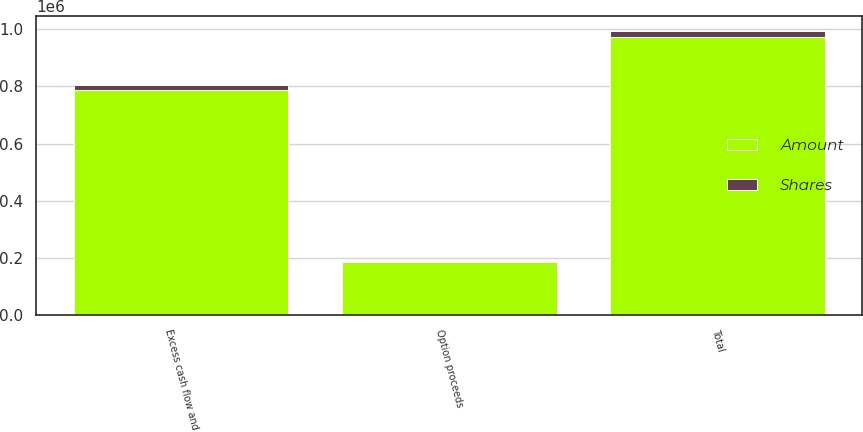<chart> <loc_0><loc_0><loc_500><loc_500><stacked_bar_chart><ecel><fcel>Excess cash flow and<fcel>Option proceeds<fcel>Total<nl><fcel>Shares<fcel>18901<fcel>4380<fcel>23281<nl><fcel>Amount<fcel>787697<fcel>184859<fcel>972556<nl></chart> 